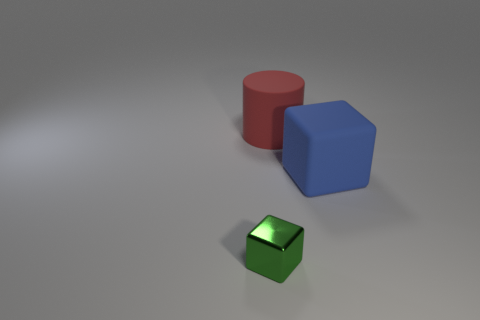Is there any other thing that is the same size as the blue object?
Offer a very short reply. Yes. There is a block that is right of the green metal block; is it the same size as the green cube that is in front of the big blue thing?
Keep it short and to the point. No. There is a object that is on the right side of the large matte cylinder; how big is it?
Keep it short and to the point. Large. There is a matte cylinder that is the same size as the blue thing; what is its color?
Offer a terse response. Red. Is the size of the red rubber thing the same as the metallic object?
Make the answer very short. No. There is a object that is both on the left side of the blue object and in front of the large rubber cylinder; what size is it?
Provide a short and direct response. Small. What number of matte objects are large blue objects or large cylinders?
Offer a terse response. 2. Is the number of metal blocks in front of the tiny green metal block greater than the number of green objects?
Your response must be concise. No. What is the material of the cube behind the metal thing?
Ensure brevity in your answer.  Rubber. What number of blue blocks have the same material as the red cylinder?
Provide a short and direct response. 1. 